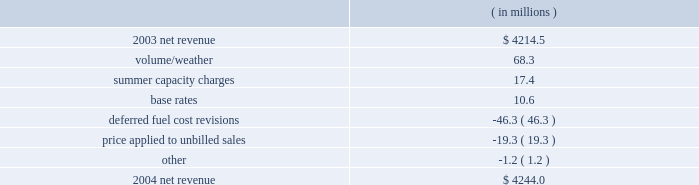Entergy corporation and subsidiaries management's financial discussion and analysis net revenue 2004 compared to 2003 net revenue , which is entergy's measure of gross margin , consists of operating revenues net of : 1 ) fuel , fuel-related , and purchased power expenses and 2 ) other regulatory credits .
Following is an analysis of the change in net revenue comparing 2004 to 2003. .
The volume/weather variance resulted primarily from increased usage , partially offset by the effect of milder weather on sales during 2004 compared to 2003 .
Billed usage increased a total of 2261 gwh in the industrial and commercial sectors .
The summer capacity charges variance was due to the amortization in 2003 at entergy gulf states and entergy louisiana of deferred capacity charges for the summer of 2001 .
Entergy gulf states' amortization began in june 2002 and ended in may 2003 .
Entergy louisiana's amortization began in august 2002 and ended in july 2003 .
Base rates increased net revenue due to a base rate increase at entergy new orleans that became effective in june 2003 .
The deferred fuel cost revisions variance resulted primarily from a revision in 2003 to an unbilled sales pricing estimate to more closely align the fuel component of that pricing with expected recoverable fuel costs at entergy louisiana .
Deferred fuel cost revisions also decreased net revenue due to a revision in 2004 to the estimate of fuel costs filed for recovery at entergy arkansas in the march 2004 energy cost recovery rider .
The price applied to unbilled sales variance resulted from a decrease in fuel price in 2004 caused primarily by the effect of nuclear plant outages in 2003 on average fuel costs .
Gross operating revenues and regulatory credits gross operating revenues include an increase in fuel cost recovery revenues of $ 475 million and $ 18 million in electric and gas sales , respectively , primarily due to higher fuel rates in 2004 resulting from increases in the market prices of purchased power and natural gas .
As such , this revenue increase is offset by increased fuel and purchased power expenses .
Other regulatory credits increased primarily due to the following : 2022 cessation of the grand gulf accelerated recovery tariff that was suspended in july 2003 ; 2022 the amortization in 2003 of deferred capacity charges for summer 2001 power purchases at entergy gulf states and entergy louisiana ; 2022 the deferral in 2004 of $ 14.3 million of capacity charges related to generation resource planning as allowed by the lpsc ; 2022 the deferral in 2004 by entergy louisiana of $ 11.4 million related to the voluntary severance program , in accordance with a proposed stipulation entered into with the lpsc staff ; and .
What is the net change in net revenue during 2004 for entergy corporation? 
Computations: (4244.0 - 4214.5)
Answer: 29.5. Entergy corporation and subsidiaries management's financial discussion and analysis net revenue 2004 compared to 2003 net revenue , which is entergy's measure of gross margin , consists of operating revenues net of : 1 ) fuel , fuel-related , and purchased power expenses and 2 ) other regulatory credits .
Following is an analysis of the change in net revenue comparing 2004 to 2003. .
The volume/weather variance resulted primarily from increased usage , partially offset by the effect of milder weather on sales during 2004 compared to 2003 .
Billed usage increased a total of 2261 gwh in the industrial and commercial sectors .
The summer capacity charges variance was due to the amortization in 2003 at entergy gulf states and entergy louisiana of deferred capacity charges for the summer of 2001 .
Entergy gulf states' amortization began in june 2002 and ended in may 2003 .
Entergy louisiana's amortization began in august 2002 and ended in july 2003 .
Base rates increased net revenue due to a base rate increase at entergy new orleans that became effective in june 2003 .
The deferred fuel cost revisions variance resulted primarily from a revision in 2003 to an unbilled sales pricing estimate to more closely align the fuel component of that pricing with expected recoverable fuel costs at entergy louisiana .
Deferred fuel cost revisions also decreased net revenue due to a revision in 2004 to the estimate of fuel costs filed for recovery at entergy arkansas in the march 2004 energy cost recovery rider .
The price applied to unbilled sales variance resulted from a decrease in fuel price in 2004 caused primarily by the effect of nuclear plant outages in 2003 on average fuel costs .
Gross operating revenues and regulatory credits gross operating revenues include an increase in fuel cost recovery revenues of $ 475 million and $ 18 million in electric and gas sales , respectively , primarily due to higher fuel rates in 2004 resulting from increases in the market prices of purchased power and natural gas .
As such , this revenue increase is offset by increased fuel and purchased power expenses .
Other regulatory credits increased primarily due to the following : 2022 cessation of the grand gulf accelerated recovery tariff that was suspended in july 2003 ; 2022 the amortization in 2003 of deferred capacity charges for summer 2001 power purchases at entergy gulf states and entergy louisiana ; 2022 the deferral in 2004 of $ 14.3 million of capacity charges related to generation resource planning as allowed by the lpsc ; 2022 the deferral in 2004 by entergy louisiana of $ 11.4 million related to the voluntary severance program , in accordance with a proposed stipulation entered into with the lpsc staff ; and .
What is the growth rate in net revenue in 2004 for entergy corporation? 
Computations: ((4244.0 - 4214.5) / 4214.5)
Answer: 0.007. 